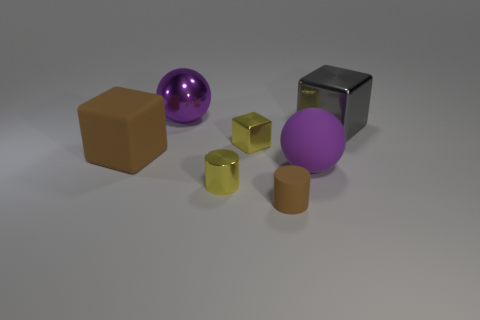Add 3 yellow things. How many objects exist? 10 Subtract all cylinders. How many objects are left? 5 Subtract all small matte cylinders. Subtract all large brown blocks. How many objects are left? 5 Add 6 yellow metal cylinders. How many yellow metal cylinders are left? 7 Add 7 rubber objects. How many rubber objects exist? 10 Subtract 0 cyan cylinders. How many objects are left? 7 